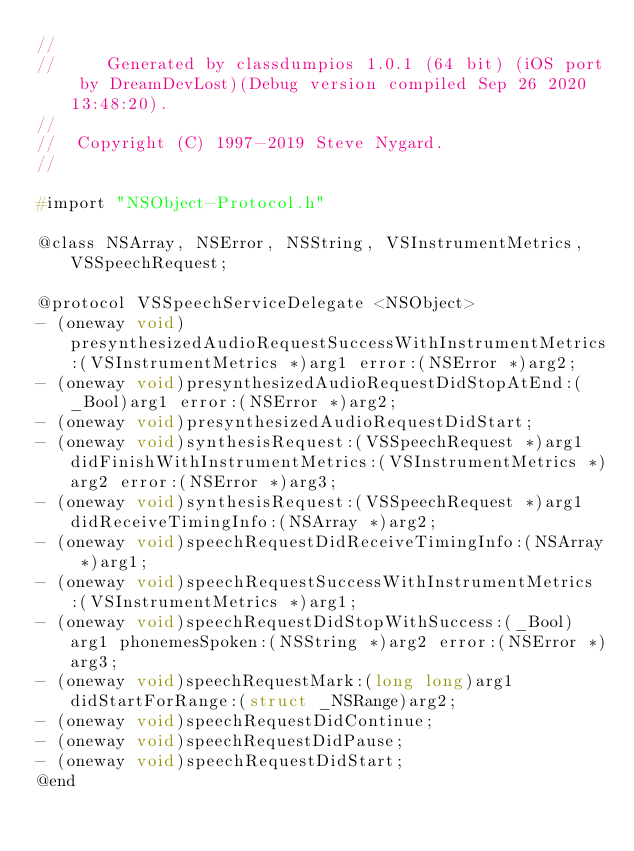Convert code to text. <code><loc_0><loc_0><loc_500><loc_500><_C_>//
//     Generated by classdumpios 1.0.1 (64 bit) (iOS port by DreamDevLost)(Debug version compiled Sep 26 2020 13:48:20).
//
//  Copyright (C) 1997-2019 Steve Nygard.
//

#import "NSObject-Protocol.h"

@class NSArray, NSError, NSString, VSInstrumentMetrics, VSSpeechRequest;

@protocol VSSpeechServiceDelegate <NSObject>
- (oneway void)presynthesizedAudioRequestSuccessWithInstrumentMetrics:(VSInstrumentMetrics *)arg1 error:(NSError *)arg2;
- (oneway void)presynthesizedAudioRequestDidStopAtEnd:(_Bool)arg1 error:(NSError *)arg2;
- (oneway void)presynthesizedAudioRequestDidStart;
- (oneway void)synthesisRequest:(VSSpeechRequest *)arg1 didFinishWithInstrumentMetrics:(VSInstrumentMetrics *)arg2 error:(NSError *)arg3;
- (oneway void)synthesisRequest:(VSSpeechRequest *)arg1 didReceiveTimingInfo:(NSArray *)arg2;
- (oneway void)speechRequestDidReceiveTimingInfo:(NSArray *)arg1;
- (oneway void)speechRequestSuccessWithInstrumentMetrics:(VSInstrumentMetrics *)arg1;
- (oneway void)speechRequestDidStopWithSuccess:(_Bool)arg1 phonemesSpoken:(NSString *)arg2 error:(NSError *)arg3;
- (oneway void)speechRequestMark:(long long)arg1 didStartForRange:(struct _NSRange)arg2;
- (oneway void)speechRequestDidContinue;
- (oneway void)speechRequestDidPause;
- (oneway void)speechRequestDidStart;
@end

</code> 